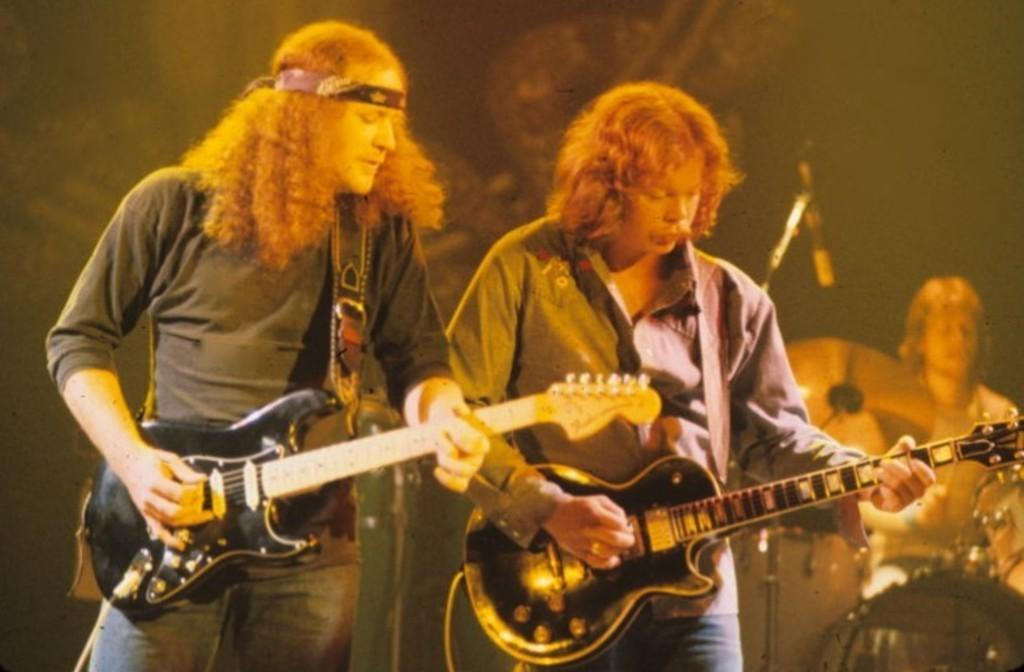What are the two people in the image doing? The two people in the image are playing guitar. Can you describe the musical instruments in the image? There is a person standing in front of musical instruments in the background of the image. What type of cave can be seen in the background of the image? There is no cave present in the image; it features two people playing guitar and a person standing in front of musical instruments. 